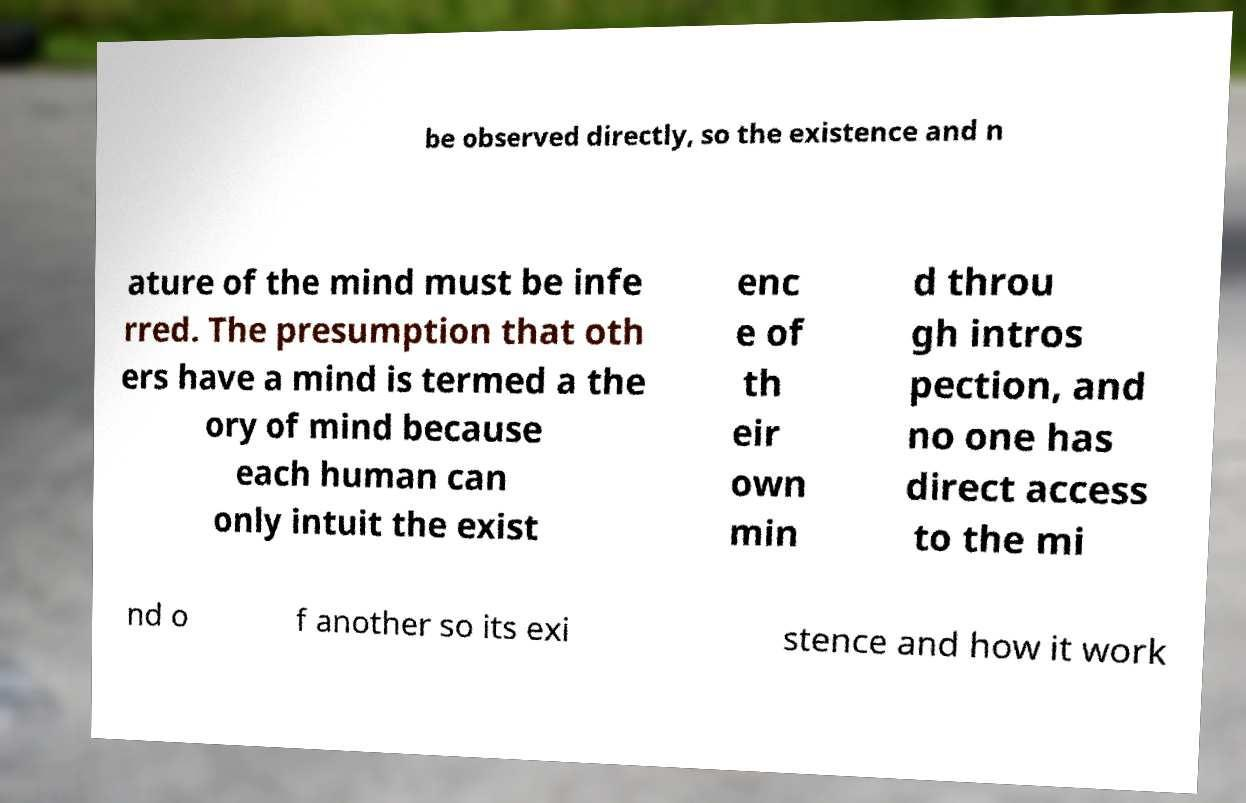There's text embedded in this image that I need extracted. Can you transcribe it verbatim? be observed directly, so the existence and n ature of the mind must be infe rred. The presumption that oth ers have a mind is termed a the ory of mind because each human can only intuit the exist enc e of th eir own min d throu gh intros pection, and no one has direct access to the mi nd o f another so its exi stence and how it work 